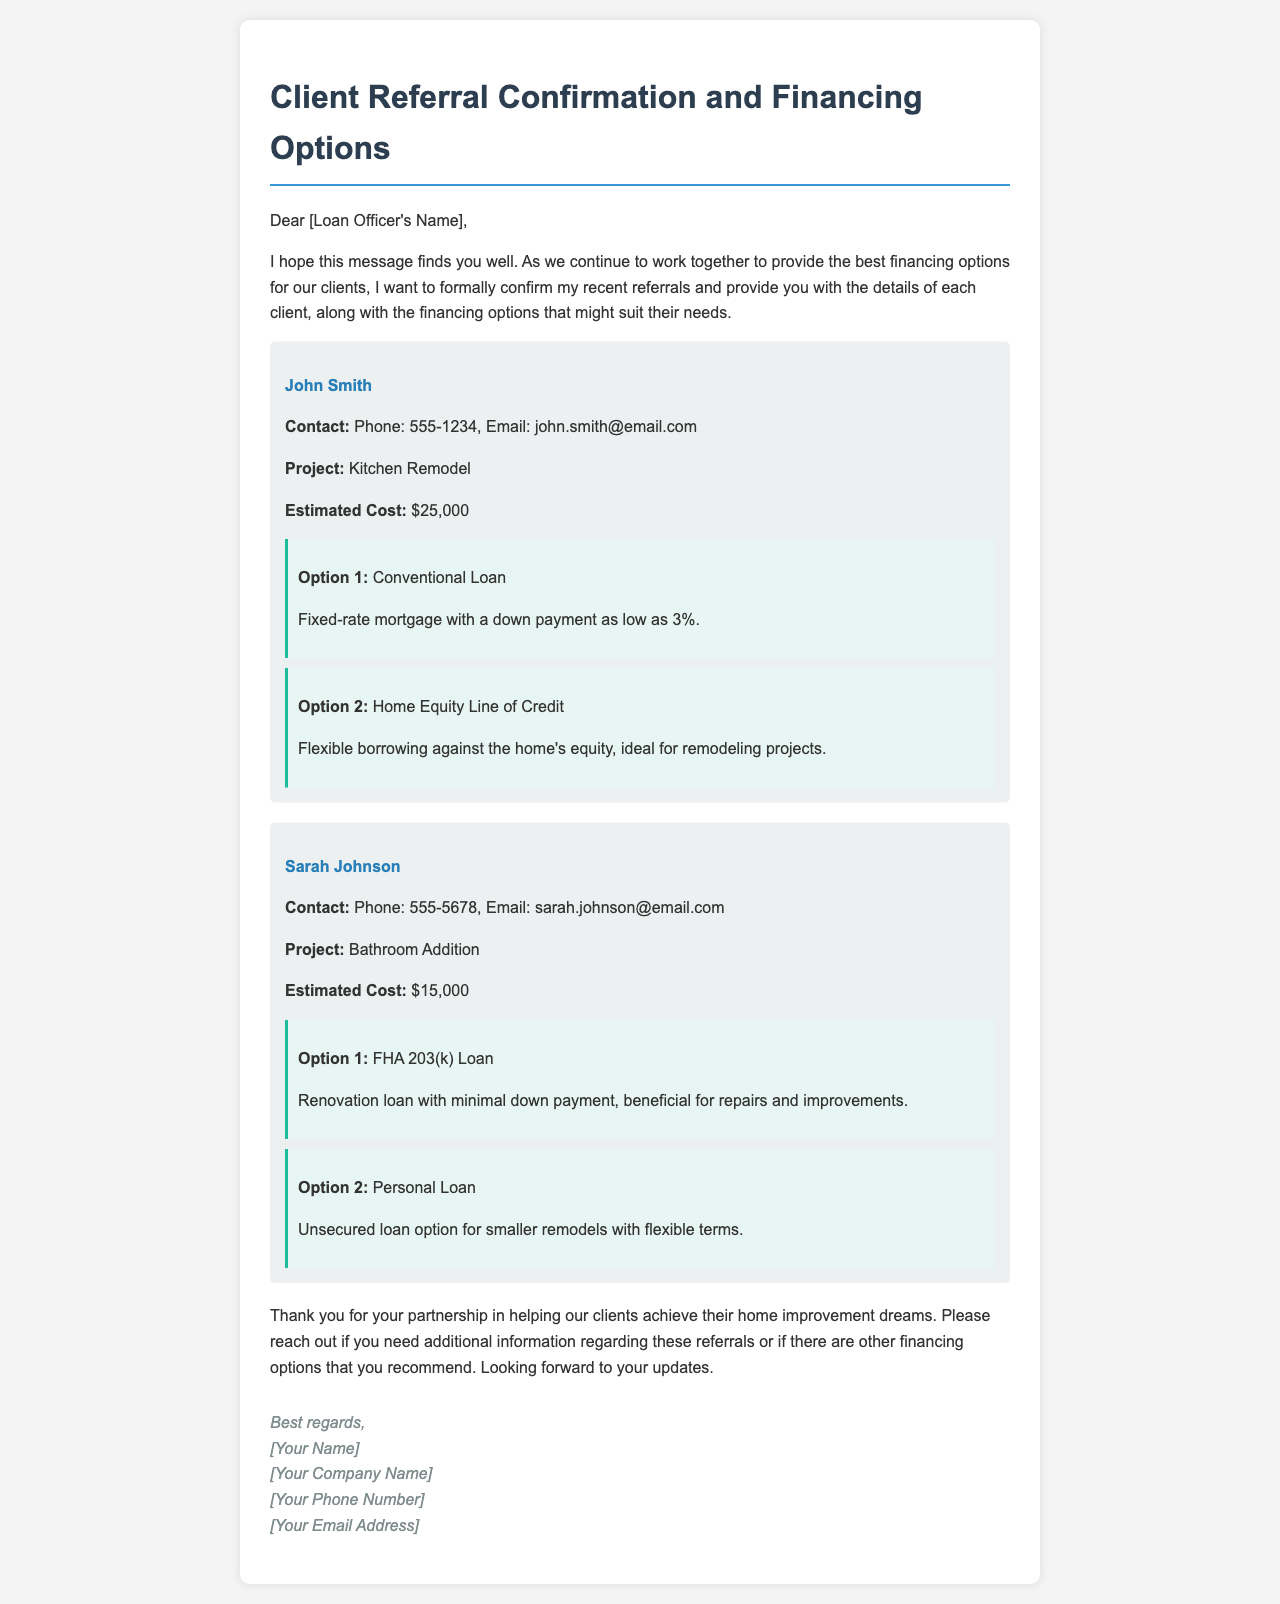What is the name of the first referred client? The name of the first referred client is mentioned in the client information section as John Smith.
Answer: John Smith What is Sarah Johnson's estimated project cost? The estimated project cost for Sarah Johnson's bathroom addition is outlined in the document as $15,000.
Answer: $15,000 What type of loan is mentioned for John Smith's project? Two financing options are provided for John Smith, one of which is a Conventional Loan.
Answer: Conventional Loan How many financing options are listed for Sarah Johnson? The document states that there are two financing options provided for Sarah Johnson's project.
Answer: Two What is the contact email for John Smith? The document includes John's contact details, noting that his email is john.smith@email.com.
Answer: john.smith@email.com What is the total estimated cost for all referred projects? The total estimated costs are $25,000 for John Smith and $15,000 for Sarah Johnson, summing up to $40,000.
Answer: $40,000 Which financing option for John Smith involves borrowing against home equity? The document specifies the Home Equity Line of Credit as a financing option ideal for remodeling projects.
Answer: Home Equity Line of Credit What is the project type for Sarah Johnson? The document indicates that Sarah Johnson's project involves a bathroom addition.
Answer: Bathroom Addition Who is the email addressed to? The email is addressed to the Loan Officer, whose name is a placeholder [Loan Officer's Name].
Answer: [Loan Officer's Name] 